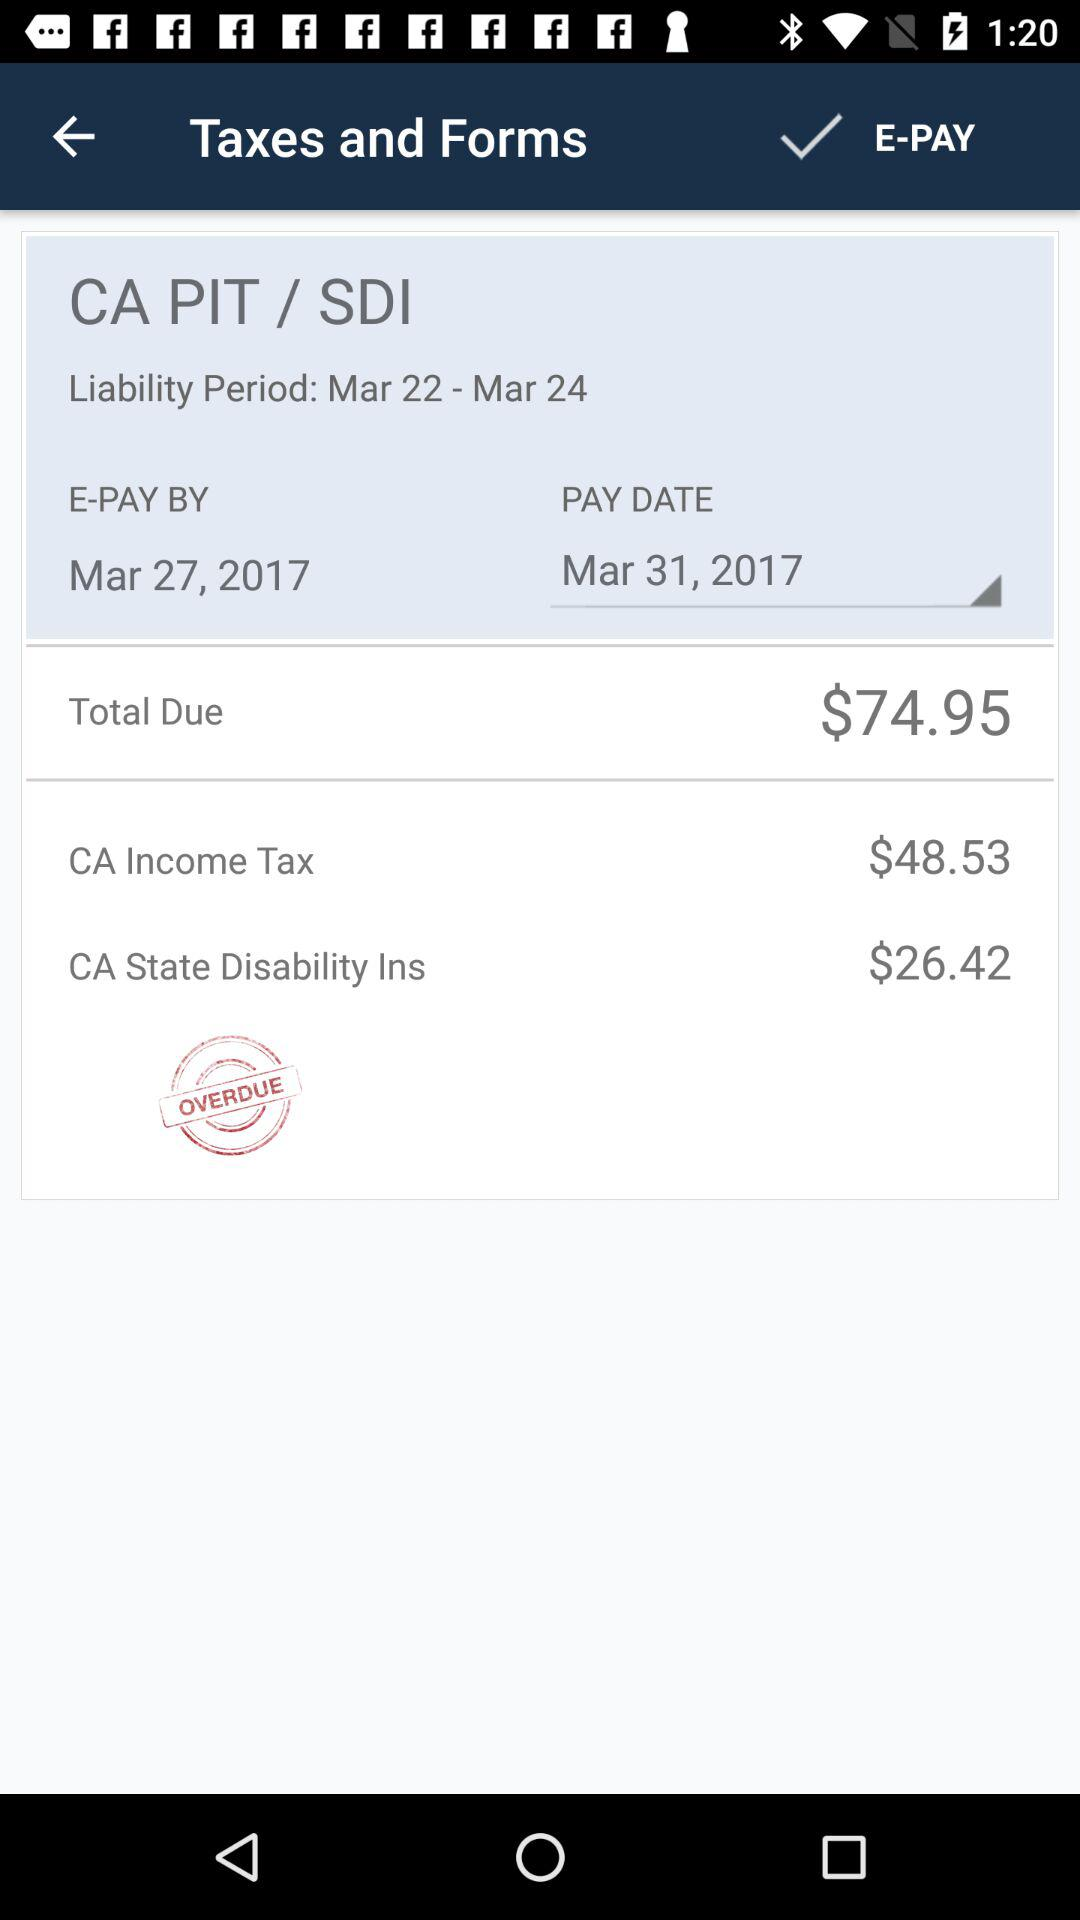How much is the total due amount?
Answer the question using a single word or phrase. $74.95 